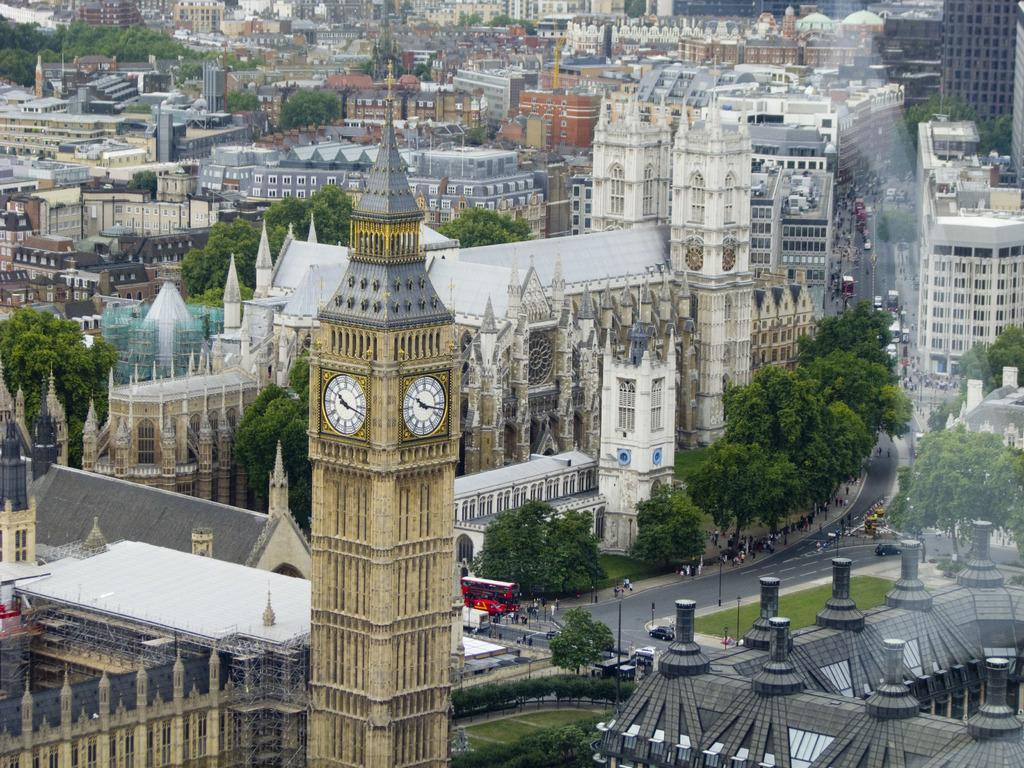What type of view is depicted in the image? The image is an aerial view. What is one prominent feature visible in the image? There is a clock tower in the image. What type of vegetation can be seen in the image? There are trees in the image. What type of transportation infrastructure is present in the image? There is a road in the image. What type of vehicles can be seen on the road? There are vehicles in the image. What type of structures are present in the image? There are poles and buildings in the image. Are there any people visible in the image? Yes, there are persons in the image. What is the title of the book being read by the train in the image? There is no train present in the image, so it is not possible to determine the title of a book being read by a train. 